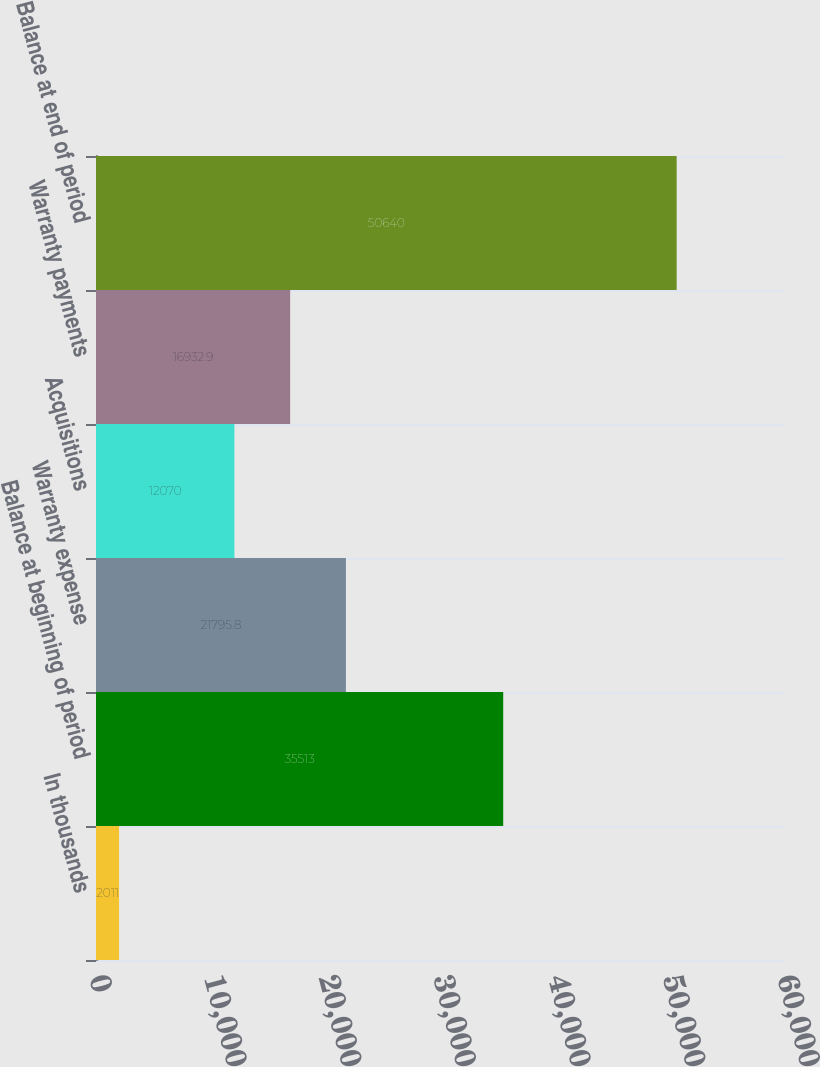<chart> <loc_0><loc_0><loc_500><loc_500><bar_chart><fcel>In thousands<fcel>Balance at beginning of period<fcel>Warranty expense<fcel>Acquisitions<fcel>Warranty payments<fcel>Balance at end of period<nl><fcel>2011<fcel>35513<fcel>21795.8<fcel>12070<fcel>16932.9<fcel>50640<nl></chart> 